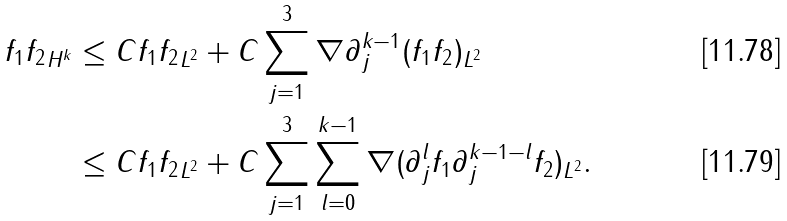<formula> <loc_0><loc_0><loc_500><loc_500>\| f _ { 1 } f _ { 2 } \| _ { H ^ { k } } & \leq C \| f _ { 1 } f _ { 2 } \| _ { L ^ { 2 } } + C \sum _ { j = 1 } ^ { 3 } \| \nabla \partial _ { j } ^ { k - 1 } ( f _ { 1 } f _ { 2 } ) \| _ { L ^ { 2 } } \\ & \leq C \| f _ { 1 } f _ { 2 } \| _ { L ^ { 2 } } + C \sum _ { j = 1 } ^ { 3 } \sum _ { l = 0 } ^ { k - 1 } \| \nabla ( \partial _ { j } ^ { l } f _ { 1 } \partial _ { j } ^ { k - 1 - l } f _ { 2 } ) \| _ { L ^ { 2 } } .</formula> 